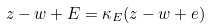<formula> <loc_0><loc_0><loc_500><loc_500>z - w + E = \kappa _ { E } ( z - w + e )</formula> 